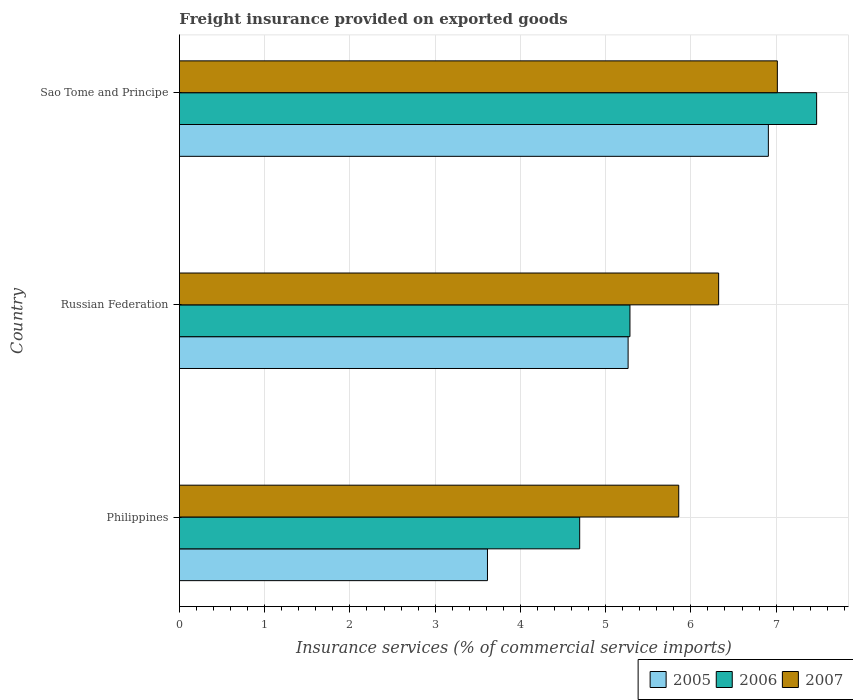How many different coloured bars are there?
Offer a terse response. 3. How many groups of bars are there?
Offer a very short reply. 3. Are the number of bars per tick equal to the number of legend labels?
Ensure brevity in your answer.  Yes. How many bars are there on the 2nd tick from the top?
Offer a very short reply. 3. What is the label of the 2nd group of bars from the top?
Your answer should be very brief. Russian Federation. In how many cases, is the number of bars for a given country not equal to the number of legend labels?
Your answer should be compact. 0. What is the freight insurance provided on exported goods in 2007 in Sao Tome and Principe?
Make the answer very short. 7.01. Across all countries, what is the maximum freight insurance provided on exported goods in 2005?
Provide a short and direct response. 6.91. Across all countries, what is the minimum freight insurance provided on exported goods in 2005?
Your answer should be compact. 3.61. In which country was the freight insurance provided on exported goods in 2006 maximum?
Your answer should be very brief. Sao Tome and Principe. What is the total freight insurance provided on exported goods in 2006 in the graph?
Your answer should be compact. 17.46. What is the difference between the freight insurance provided on exported goods in 2005 in Russian Federation and that in Sao Tome and Principe?
Provide a succinct answer. -1.65. What is the difference between the freight insurance provided on exported goods in 2005 in Russian Federation and the freight insurance provided on exported goods in 2006 in Sao Tome and Principe?
Give a very brief answer. -2.21. What is the average freight insurance provided on exported goods in 2006 per country?
Make the answer very short. 5.82. What is the difference between the freight insurance provided on exported goods in 2007 and freight insurance provided on exported goods in 2005 in Philippines?
Make the answer very short. 2.24. In how many countries, is the freight insurance provided on exported goods in 2006 greater than 4.2 %?
Your answer should be very brief. 3. What is the ratio of the freight insurance provided on exported goods in 2006 in Philippines to that in Sao Tome and Principe?
Provide a short and direct response. 0.63. What is the difference between the highest and the second highest freight insurance provided on exported goods in 2007?
Provide a succinct answer. 0.69. What is the difference between the highest and the lowest freight insurance provided on exported goods in 2005?
Provide a short and direct response. 3.3. In how many countries, is the freight insurance provided on exported goods in 2007 greater than the average freight insurance provided on exported goods in 2007 taken over all countries?
Keep it short and to the point. 1. Is the sum of the freight insurance provided on exported goods in 2005 in Philippines and Russian Federation greater than the maximum freight insurance provided on exported goods in 2006 across all countries?
Offer a very short reply. Yes. What does the 2nd bar from the bottom in Sao Tome and Principe represents?
Your answer should be very brief. 2006. Is it the case that in every country, the sum of the freight insurance provided on exported goods in 2007 and freight insurance provided on exported goods in 2006 is greater than the freight insurance provided on exported goods in 2005?
Make the answer very short. Yes. Are the values on the major ticks of X-axis written in scientific E-notation?
Offer a terse response. No. Does the graph contain any zero values?
Keep it short and to the point. No. What is the title of the graph?
Offer a terse response. Freight insurance provided on exported goods. Does "2009" appear as one of the legend labels in the graph?
Keep it short and to the point. No. What is the label or title of the X-axis?
Your response must be concise. Insurance services (% of commercial service imports). What is the label or title of the Y-axis?
Ensure brevity in your answer.  Country. What is the Insurance services (% of commercial service imports) in 2005 in Philippines?
Offer a very short reply. 3.61. What is the Insurance services (% of commercial service imports) in 2006 in Philippines?
Your response must be concise. 4.7. What is the Insurance services (% of commercial service imports) of 2007 in Philippines?
Make the answer very short. 5.86. What is the Insurance services (% of commercial service imports) of 2005 in Russian Federation?
Offer a terse response. 5.26. What is the Insurance services (% of commercial service imports) of 2006 in Russian Federation?
Offer a terse response. 5.29. What is the Insurance services (% of commercial service imports) in 2007 in Russian Federation?
Your answer should be compact. 6.33. What is the Insurance services (% of commercial service imports) of 2005 in Sao Tome and Principe?
Give a very brief answer. 6.91. What is the Insurance services (% of commercial service imports) in 2006 in Sao Tome and Principe?
Keep it short and to the point. 7.48. What is the Insurance services (% of commercial service imports) in 2007 in Sao Tome and Principe?
Give a very brief answer. 7.01. Across all countries, what is the maximum Insurance services (% of commercial service imports) of 2005?
Offer a terse response. 6.91. Across all countries, what is the maximum Insurance services (% of commercial service imports) of 2006?
Keep it short and to the point. 7.48. Across all countries, what is the maximum Insurance services (% of commercial service imports) of 2007?
Your response must be concise. 7.01. Across all countries, what is the minimum Insurance services (% of commercial service imports) in 2005?
Offer a terse response. 3.61. Across all countries, what is the minimum Insurance services (% of commercial service imports) of 2006?
Your response must be concise. 4.7. Across all countries, what is the minimum Insurance services (% of commercial service imports) of 2007?
Provide a succinct answer. 5.86. What is the total Insurance services (% of commercial service imports) in 2005 in the graph?
Ensure brevity in your answer.  15.79. What is the total Insurance services (% of commercial service imports) in 2006 in the graph?
Offer a very short reply. 17.46. What is the total Insurance services (% of commercial service imports) of 2007 in the graph?
Make the answer very short. 19.2. What is the difference between the Insurance services (% of commercial service imports) of 2005 in Philippines and that in Russian Federation?
Your answer should be compact. -1.65. What is the difference between the Insurance services (% of commercial service imports) in 2006 in Philippines and that in Russian Federation?
Your answer should be very brief. -0.59. What is the difference between the Insurance services (% of commercial service imports) of 2007 in Philippines and that in Russian Federation?
Provide a short and direct response. -0.47. What is the difference between the Insurance services (% of commercial service imports) of 2005 in Philippines and that in Sao Tome and Principe?
Give a very brief answer. -3.3. What is the difference between the Insurance services (% of commercial service imports) in 2006 in Philippines and that in Sao Tome and Principe?
Offer a terse response. -2.78. What is the difference between the Insurance services (% of commercial service imports) of 2007 in Philippines and that in Sao Tome and Principe?
Your response must be concise. -1.16. What is the difference between the Insurance services (% of commercial service imports) in 2005 in Russian Federation and that in Sao Tome and Principe?
Ensure brevity in your answer.  -1.65. What is the difference between the Insurance services (% of commercial service imports) of 2006 in Russian Federation and that in Sao Tome and Principe?
Provide a short and direct response. -2.19. What is the difference between the Insurance services (% of commercial service imports) in 2007 in Russian Federation and that in Sao Tome and Principe?
Offer a very short reply. -0.69. What is the difference between the Insurance services (% of commercial service imports) of 2005 in Philippines and the Insurance services (% of commercial service imports) of 2006 in Russian Federation?
Give a very brief answer. -1.67. What is the difference between the Insurance services (% of commercial service imports) of 2005 in Philippines and the Insurance services (% of commercial service imports) of 2007 in Russian Federation?
Your answer should be compact. -2.71. What is the difference between the Insurance services (% of commercial service imports) of 2006 in Philippines and the Insurance services (% of commercial service imports) of 2007 in Russian Federation?
Ensure brevity in your answer.  -1.63. What is the difference between the Insurance services (% of commercial service imports) in 2005 in Philippines and the Insurance services (% of commercial service imports) in 2006 in Sao Tome and Principe?
Make the answer very short. -3.86. What is the difference between the Insurance services (% of commercial service imports) of 2005 in Philippines and the Insurance services (% of commercial service imports) of 2007 in Sao Tome and Principe?
Make the answer very short. -3.4. What is the difference between the Insurance services (% of commercial service imports) of 2006 in Philippines and the Insurance services (% of commercial service imports) of 2007 in Sao Tome and Principe?
Offer a very short reply. -2.32. What is the difference between the Insurance services (% of commercial service imports) of 2005 in Russian Federation and the Insurance services (% of commercial service imports) of 2006 in Sao Tome and Principe?
Ensure brevity in your answer.  -2.21. What is the difference between the Insurance services (% of commercial service imports) of 2005 in Russian Federation and the Insurance services (% of commercial service imports) of 2007 in Sao Tome and Principe?
Offer a terse response. -1.75. What is the difference between the Insurance services (% of commercial service imports) of 2006 in Russian Federation and the Insurance services (% of commercial service imports) of 2007 in Sao Tome and Principe?
Your answer should be compact. -1.73. What is the average Insurance services (% of commercial service imports) of 2005 per country?
Ensure brevity in your answer.  5.26. What is the average Insurance services (% of commercial service imports) of 2006 per country?
Your answer should be very brief. 5.82. What is the average Insurance services (% of commercial service imports) in 2007 per country?
Provide a succinct answer. 6.4. What is the difference between the Insurance services (% of commercial service imports) in 2005 and Insurance services (% of commercial service imports) in 2006 in Philippines?
Ensure brevity in your answer.  -1.08. What is the difference between the Insurance services (% of commercial service imports) of 2005 and Insurance services (% of commercial service imports) of 2007 in Philippines?
Offer a very short reply. -2.24. What is the difference between the Insurance services (% of commercial service imports) in 2006 and Insurance services (% of commercial service imports) in 2007 in Philippines?
Provide a succinct answer. -1.16. What is the difference between the Insurance services (% of commercial service imports) of 2005 and Insurance services (% of commercial service imports) of 2006 in Russian Federation?
Provide a succinct answer. -0.02. What is the difference between the Insurance services (% of commercial service imports) of 2005 and Insurance services (% of commercial service imports) of 2007 in Russian Federation?
Keep it short and to the point. -1.06. What is the difference between the Insurance services (% of commercial service imports) of 2006 and Insurance services (% of commercial service imports) of 2007 in Russian Federation?
Provide a short and direct response. -1.04. What is the difference between the Insurance services (% of commercial service imports) of 2005 and Insurance services (% of commercial service imports) of 2006 in Sao Tome and Principe?
Offer a terse response. -0.57. What is the difference between the Insurance services (% of commercial service imports) in 2005 and Insurance services (% of commercial service imports) in 2007 in Sao Tome and Principe?
Your response must be concise. -0.11. What is the difference between the Insurance services (% of commercial service imports) of 2006 and Insurance services (% of commercial service imports) of 2007 in Sao Tome and Principe?
Offer a terse response. 0.46. What is the ratio of the Insurance services (% of commercial service imports) of 2005 in Philippines to that in Russian Federation?
Provide a succinct answer. 0.69. What is the ratio of the Insurance services (% of commercial service imports) in 2006 in Philippines to that in Russian Federation?
Offer a terse response. 0.89. What is the ratio of the Insurance services (% of commercial service imports) of 2007 in Philippines to that in Russian Federation?
Provide a short and direct response. 0.93. What is the ratio of the Insurance services (% of commercial service imports) in 2005 in Philippines to that in Sao Tome and Principe?
Your answer should be very brief. 0.52. What is the ratio of the Insurance services (% of commercial service imports) in 2006 in Philippines to that in Sao Tome and Principe?
Make the answer very short. 0.63. What is the ratio of the Insurance services (% of commercial service imports) of 2007 in Philippines to that in Sao Tome and Principe?
Provide a succinct answer. 0.84. What is the ratio of the Insurance services (% of commercial service imports) in 2005 in Russian Federation to that in Sao Tome and Principe?
Your response must be concise. 0.76. What is the ratio of the Insurance services (% of commercial service imports) in 2006 in Russian Federation to that in Sao Tome and Principe?
Ensure brevity in your answer.  0.71. What is the ratio of the Insurance services (% of commercial service imports) of 2007 in Russian Federation to that in Sao Tome and Principe?
Make the answer very short. 0.9. What is the difference between the highest and the second highest Insurance services (% of commercial service imports) of 2005?
Your answer should be compact. 1.65. What is the difference between the highest and the second highest Insurance services (% of commercial service imports) of 2006?
Offer a terse response. 2.19. What is the difference between the highest and the second highest Insurance services (% of commercial service imports) of 2007?
Give a very brief answer. 0.69. What is the difference between the highest and the lowest Insurance services (% of commercial service imports) in 2005?
Make the answer very short. 3.3. What is the difference between the highest and the lowest Insurance services (% of commercial service imports) in 2006?
Your response must be concise. 2.78. What is the difference between the highest and the lowest Insurance services (% of commercial service imports) in 2007?
Provide a short and direct response. 1.16. 